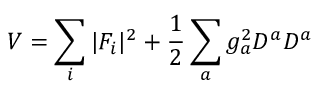<formula> <loc_0><loc_0><loc_500><loc_500>V = \sum _ { i } | F _ { i } | ^ { 2 } + \frac { 1 } { 2 } \sum _ { a } g _ { a } ^ { 2 } D ^ { a } D ^ { a }</formula> 